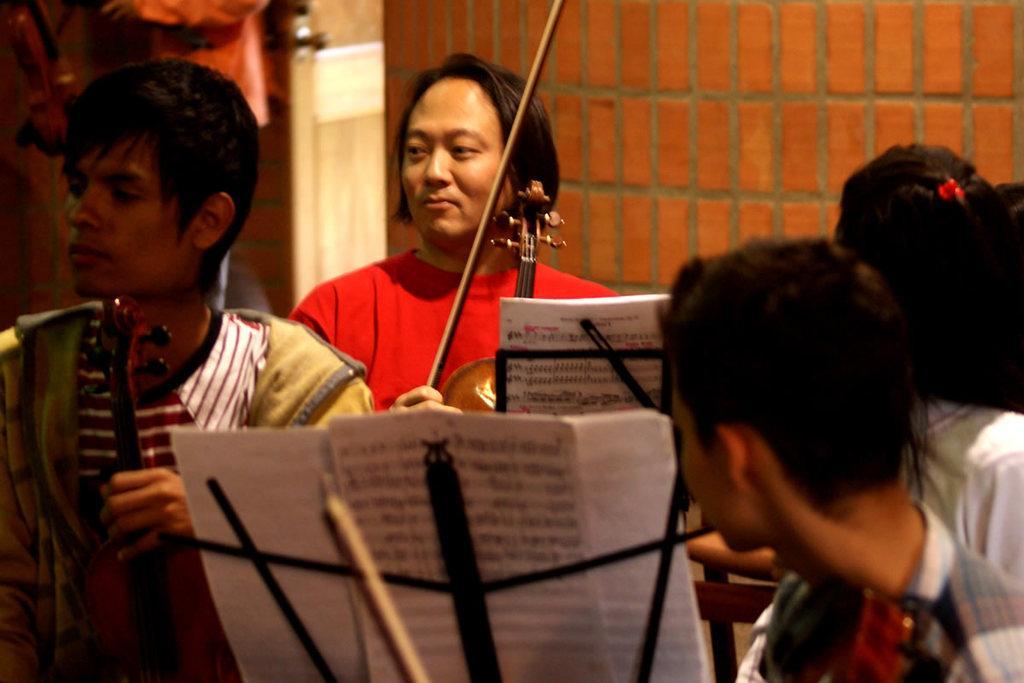Please provide a concise description of this image. This picture describe about a group of boys playing guitar and violin. In front we can see a boy wearing brown jacket and playing the guitar, behind a man wearing red t- shirt is holding violin and a stick in this hand and smiling into camera, On the left we can see a boy is watching to him, In middle a musical notes on the stand and a red brick wall in behind. 